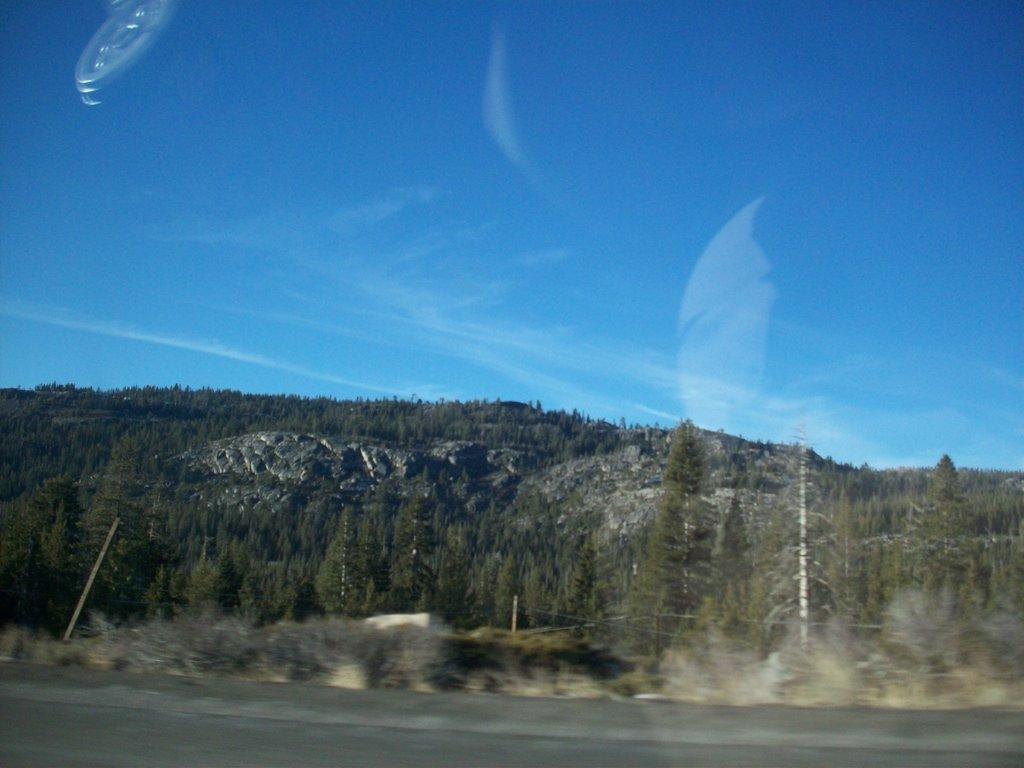What is the main subject of the image? The main subject of the image is a picture with a reflection. What can be seen in the foreground of the image? There is a road in the image. What is visible in the background of the image? There is a mountain and a tree in the background of the image. What is visible at the top of the image? The sky is visible at the top of the image. How many pigs are present in the image? There are no pigs present in the image. What type of pain is depicted in the image? There is no depiction of pain in the image; it features a picture with a reflection, a road, a mountain, a tree, and the sky. 